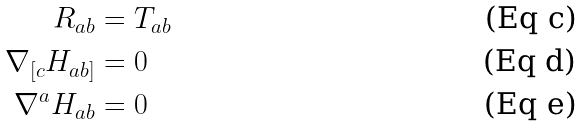Convert formula to latex. <formula><loc_0><loc_0><loc_500><loc_500>R _ { a b } & = T _ { a b } \\ \nabla _ { [ c } H _ { a b ] } & = 0 \\ \nabla ^ { a } H _ { a b } & = 0</formula> 